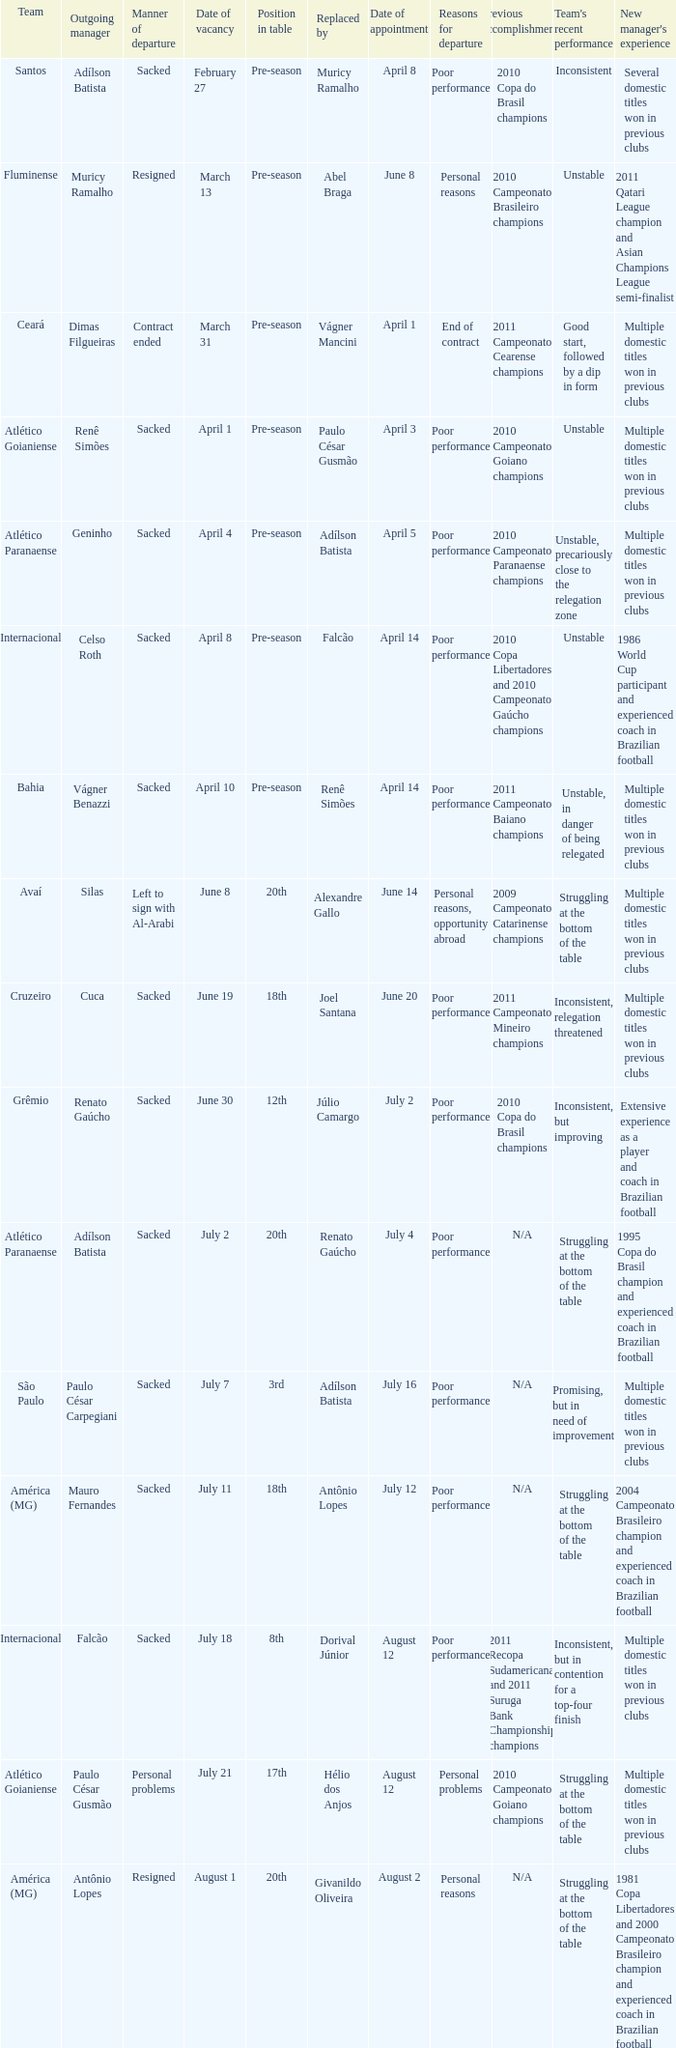Who was replaced as manager on June 20? Cuca. 